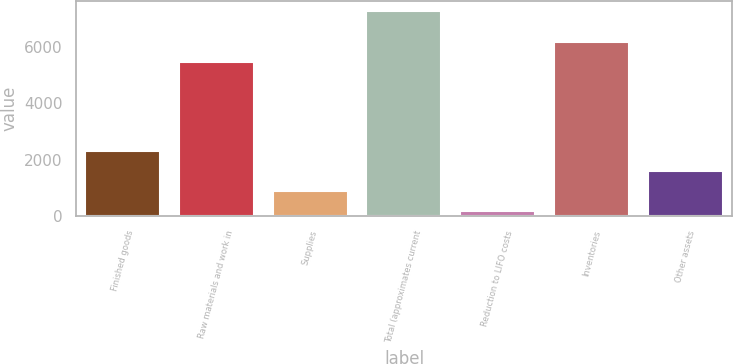<chart> <loc_0><loc_0><loc_500><loc_500><bar_chart><fcel>Finished goods<fcel>Raw materials and work in<fcel>Supplies<fcel>Total (approximates current<fcel>Reduction to LIFO costs<fcel>Inventories<fcel>Other assets<nl><fcel>2304.6<fcel>5449<fcel>892.2<fcel>7248<fcel>186<fcel>6155.2<fcel>1598.4<nl></chart> 